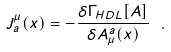<formula> <loc_0><loc_0><loc_500><loc_500>J ^ { \mu } _ { a } ( x ) = - \frac { \delta \Gamma _ { H D L } [ A ] } { \delta A _ { \mu } ^ { a } ( x ) } \ .</formula> 